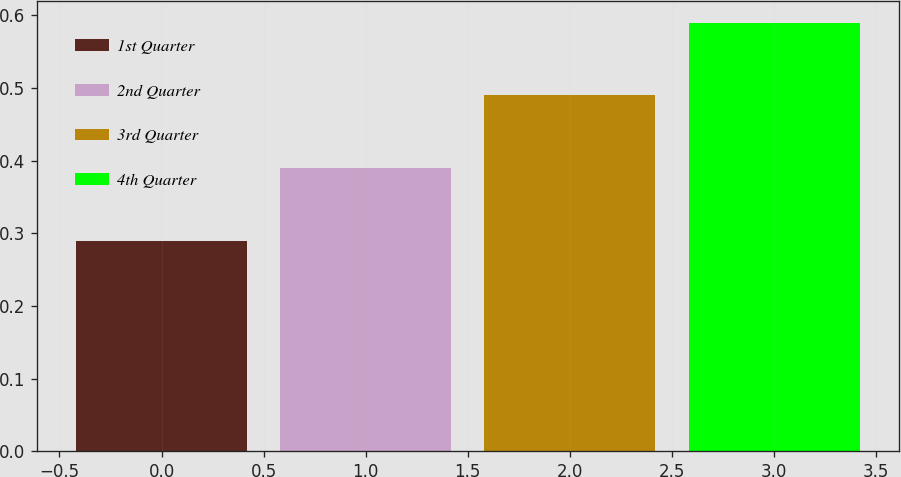<chart> <loc_0><loc_0><loc_500><loc_500><bar_chart><fcel>1st Quarter<fcel>2nd Quarter<fcel>3rd Quarter<fcel>4th Quarter<nl><fcel>0.29<fcel>0.39<fcel>0.49<fcel>0.59<nl></chart> 